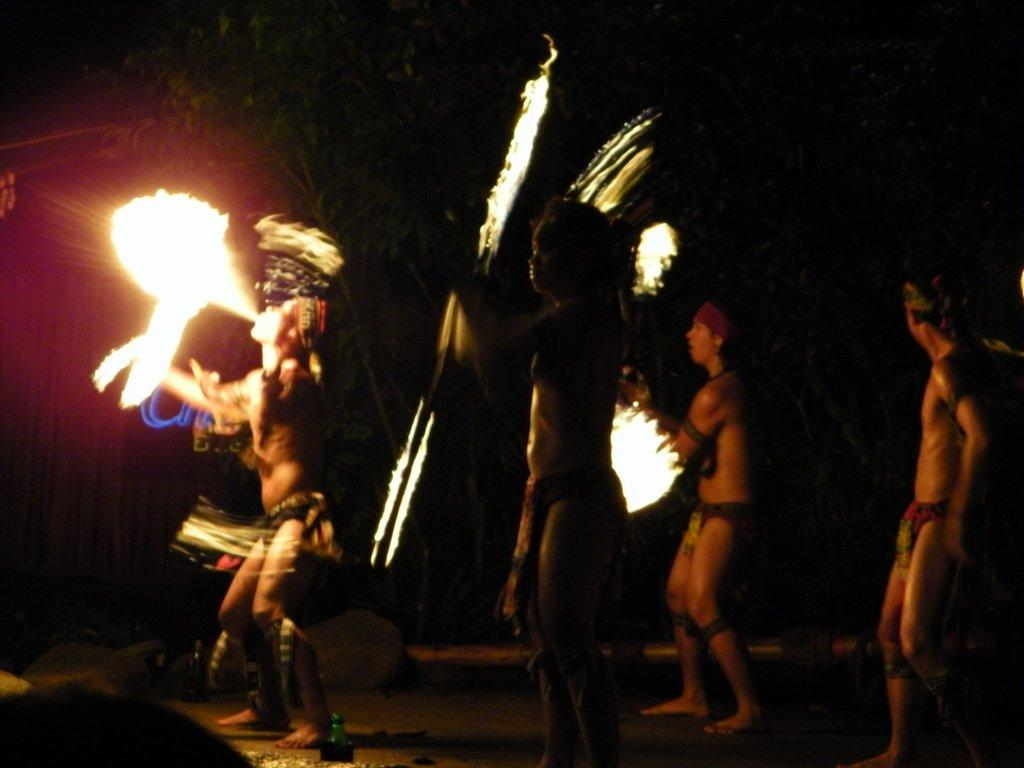How many people are in the image? There is a group of persons in the image. What are the persons holding in the image? The persons are holding fire objects. Can you describe the person holding a stick? The person with the stick is bowling fire. What can be seen in the background of the image? There are trees in the background of the image. What type of selection process is taking place in the image? There is no selection process visible in the image; it features a group of persons holding fire objects and bowling fire. What type of protest is being conducted in the image? There is no protest visible in the image; it features a group of persons holding fire objects and bowling fire. 